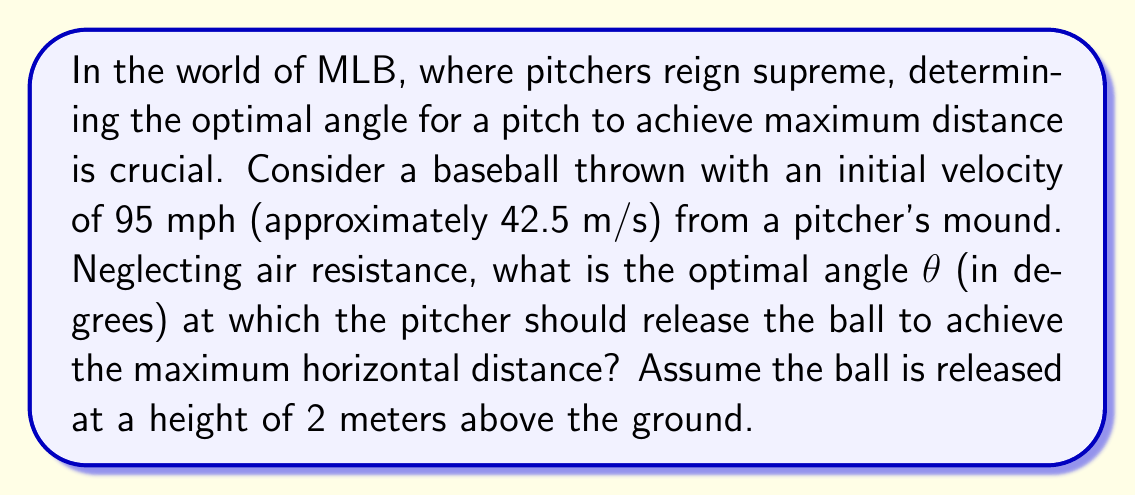Can you solve this math problem? To solve this problem, we'll use principles from projectile motion in physics, which is a perfect application of real analysis in the context of baseball.

1) The range (R) of a projectile launched from a height (h) above the ground is given by:

   $$R = \frac{v_0 \cos θ}{g} \left(v_0 \sin θ + \sqrt{v_0^2 \sin^2 θ + 2gh}\right)$$

   Where:
   $v_0$ is the initial velocity
   $g$ is the acceleration due to gravity (9.8 m/s²)
   $θ$ is the launch angle

2) To find the optimal angle, we need to maximize R with respect to θ. We can do this by taking the derivative of R with respect to θ and setting it equal to zero:

   $$\frac{dR}{dθ} = 0$$

3) However, the resulting equation is complex and difficult to solve analytically. In this case, we can use a numerical method or consider a simplification.

4) For a projectile launched from ground level (h = 0), the optimal angle is always 45°. When launched from a height, the optimal angle is slightly less than 45°.

5) Given that the release height (2 m) is relatively small compared to the distances involved in a baseball pitch, we can approximate the optimal angle to be very close to 45°.

6) To verify, we can calculate the range for angles close to 45° using the full equation:

   For θ = 44°:
   $$R = \frac{42.5 \cos 44°}{9.8} \left(42.5 \sin 44° + \sqrt{42.5^2 \sin^2 44° + 2(9.8)(2)}\right) ≈ 185.76 \text{ m}$$

   For θ = 45°:
   $$R = \frac{42.5 \cos 45°}{9.8} \left(42.5 \sin 45° + \sqrt{42.5^2 \sin^2 45° + 2(9.8)(2)}\right) ≈ 185.77 \text{ m}$$

   For θ = 46°:
   $$R = \frac{42.5 \cos 46°}{9.8} \left(42.5 \sin 46° + \sqrt{42.5^2 \sin^2 46° + 2(9.8)(2)}\right) ≈ 185.75 \text{ m}$$

7) We can see that the maximum range occurs very close to 45°, with the exact optimal angle being slightly less than 45° due to the small initial height.
Answer: The optimal angle θ for maximum horizontal distance is approximately 45°. More precisely, it is slightly less than 45°, but the difference is negligible for practical purposes in baseball pitching. 